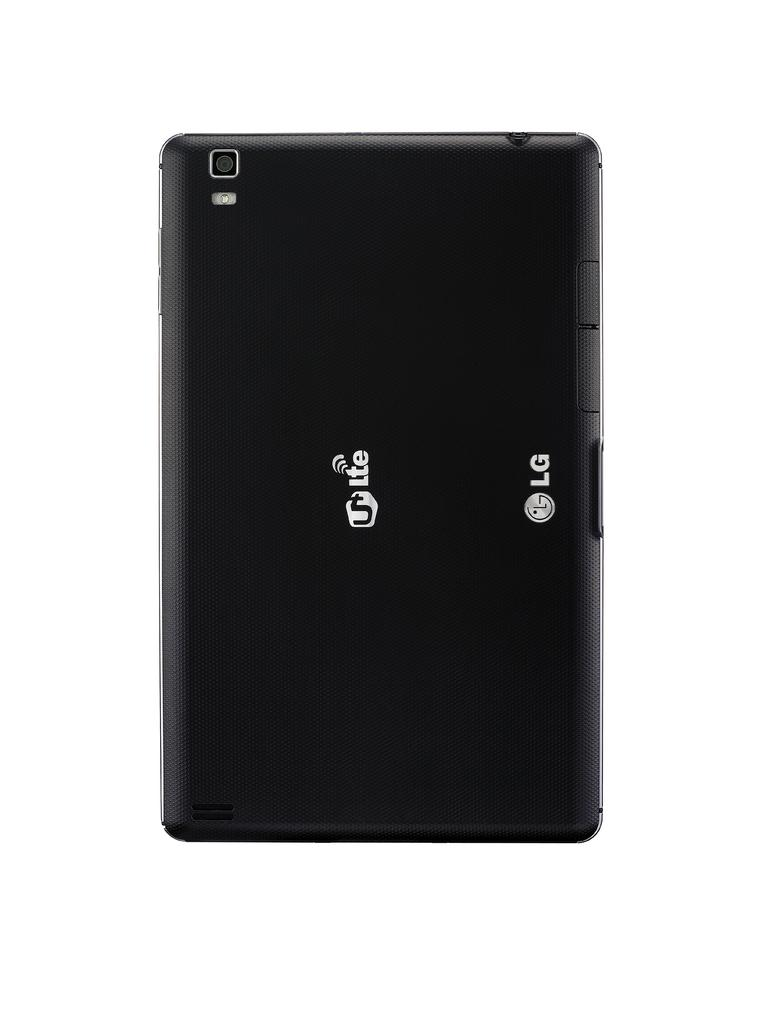<image>
Present a compact description of the photo's key features. an LG 5LTE phone on a plain white background 